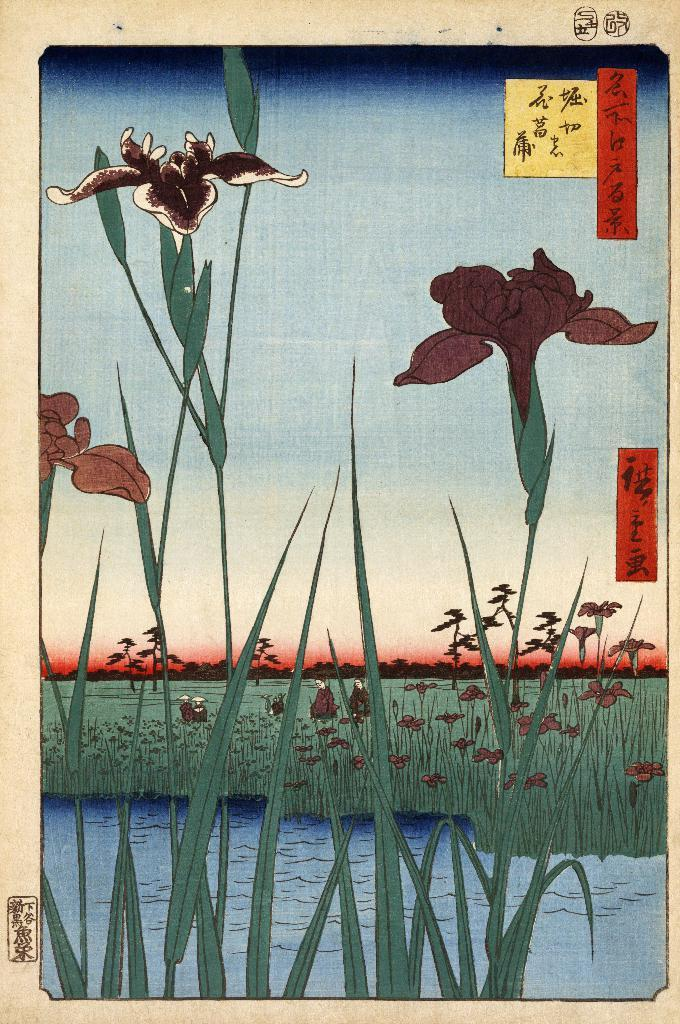What types of images are present on the paper in the image? The paper contains images of plants, flowers, grass, and water. What additional elements can be seen on the paper? There are stickers on the paper. What type of education is being taught in the image? The image does not depict any educational content or context, so it is not possible to determine what type of education is being taught. 